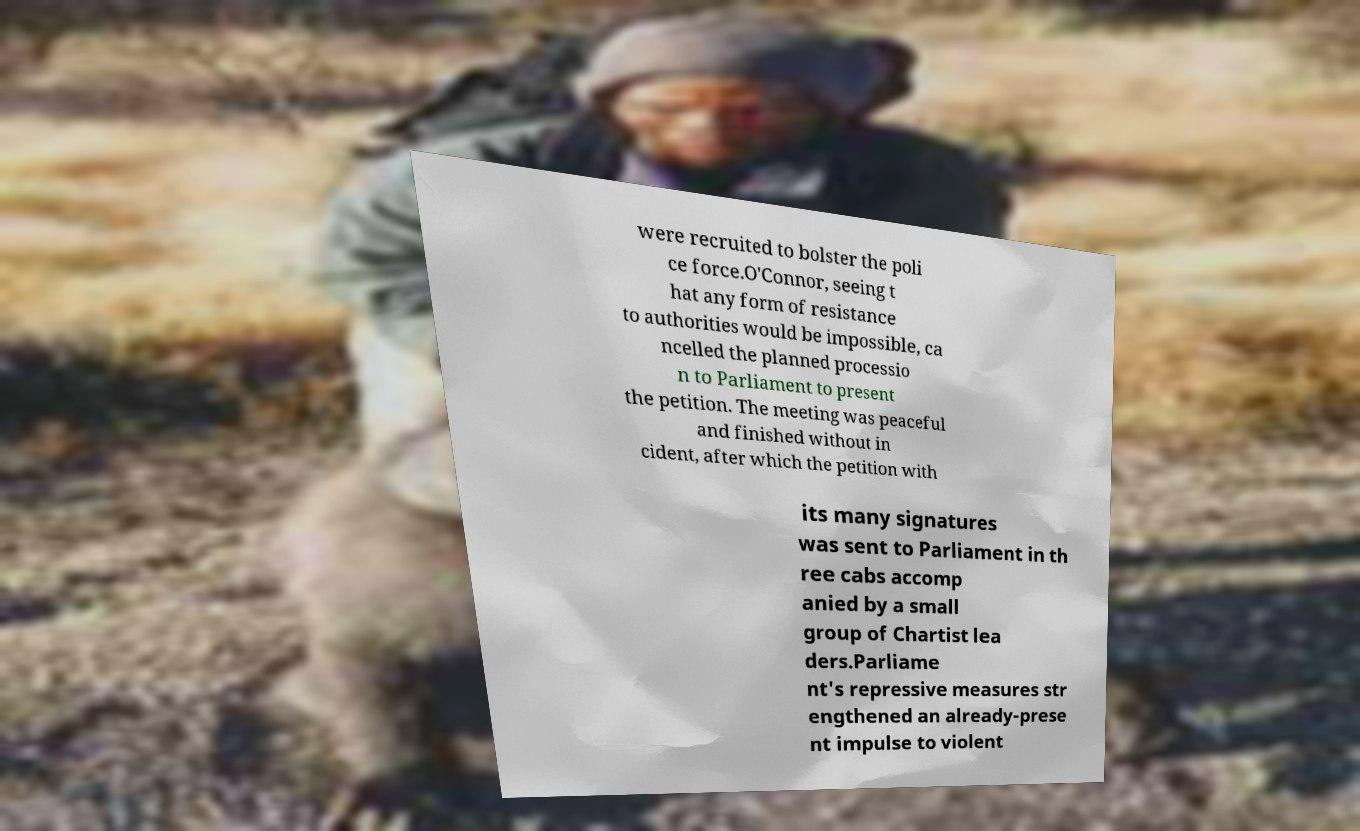What messages or text are displayed in this image? I need them in a readable, typed format. were recruited to bolster the poli ce force.O'Connor, seeing t hat any form of resistance to authorities would be impossible, ca ncelled the planned processio n to Parliament to present the petition. The meeting was peaceful and finished without in cident, after which the petition with its many signatures was sent to Parliament in th ree cabs accomp anied by a small group of Chartist lea ders.Parliame nt's repressive measures str engthened an already-prese nt impulse to violent 